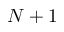<formula> <loc_0><loc_0><loc_500><loc_500>N + 1</formula> 